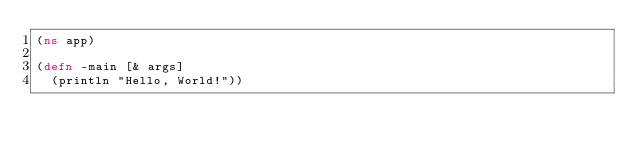<code> <loc_0><loc_0><loc_500><loc_500><_Clojure_>(ns app)

(defn -main [& args]
  (println "Hello, World!"))</code> 